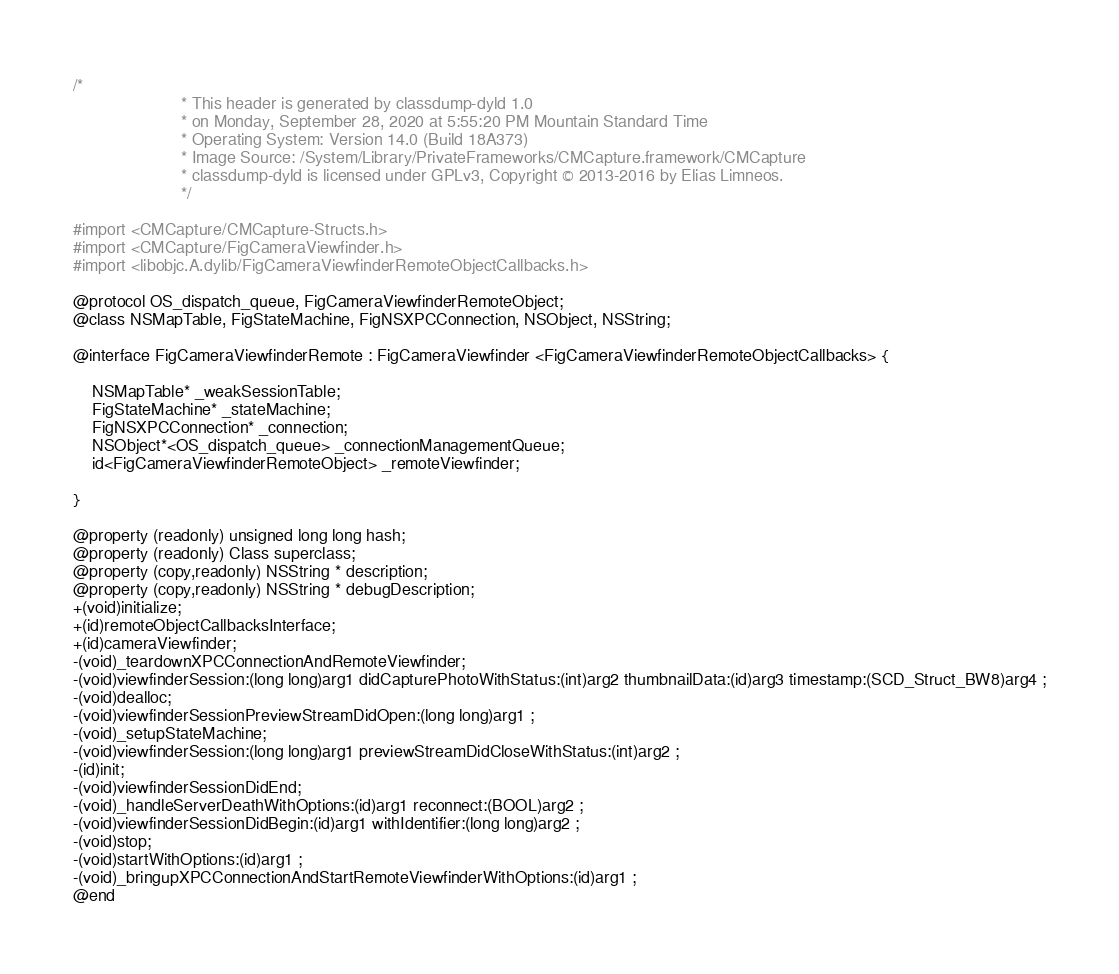<code> <loc_0><loc_0><loc_500><loc_500><_C_>/*
                       * This header is generated by classdump-dyld 1.0
                       * on Monday, September 28, 2020 at 5:55:20 PM Mountain Standard Time
                       * Operating System: Version 14.0 (Build 18A373)
                       * Image Source: /System/Library/PrivateFrameworks/CMCapture.framework/CMCapture
                       * classdump-dyld is licensed under GPLv3, Copyright © 2013-2016 by Elias Limneos.
                       */

#import <CMCapture/CMCapture-Structs.h>
#import <CMCapture/FigCameraViewfinder.h>
#import <libobjc.A.dylib/FigCameraViewfinderRemoteObjectCallbacks.h>

@protocol OS_dispatch_queue, FigCameraViewfinderRemoteObject;
@class NSMapTable, FigStateMachine, FigNSXPCConnection, NSObject, NSString;

@interface FigCameraViewfinderRemote : FigCameraViewfinder <FigCameraViewfinderRemoteObjectCallbacks> {

	NSMapTable* _weakSessionTable;
	FigStateMachine* _stateMachine;
	FigNSXPCConnection* _connection;
	NSObject*<OS_dispatch_queue> _connectionManagementQueue;
	id<FigCameraViewfinderRemoteObject> _remoteViewfinder;

}

@property (readonly) unsigned long long hash; 
@property (readonly) Class superclass; 
@property (copy,readonly) NSString * description; 
@property (copy,readonly) NSString * debugDescription; 
+(void)initialize;
+(id)remoteObjectCallbacksInterface;
+(id)cameraViewfinder;
-(void)_teardownXPCConnectionAndRemoteViewfinder;
-(void)viewfinderSession:(long long)arg1 didCapturePhotoWithStatus:(int)arg2 thumbnailData:(id)arg3 timestamp:(SCD_Struct_BW8)arg4 ;
-(void)dealloc;
-(void)viewfinderSessionPreviewStreamDidOpen:(long long)arg1 ;
-(void)_setupStateMachine;
-(void)viewfinderSession:(long long)arg1 previewStreamDidCloseWithStatus:(int)arg2 ;
-(id)init;
-(void)viewfinderSessionDidEnd;
-(void)_handleServerDeathWithOptions:(id)arg1 reconnect:(BOOL)arg2 ;
-(void)viewfinderSessionDidBegin:(id)arg1 withIdentifier:(long long)arg2 ;
-(void)stop;
-(void)startWithOptions:(id)arg1 ;
-(void)_bringupXPCConnectionAndStartRemoteViewfinderWithOptions:(id)arg1 ;
@end

</code> 